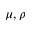Convert formula to latex. <formula><loc_0><loc_0><loc_500><loc_500>\mu , \rho</formula> 